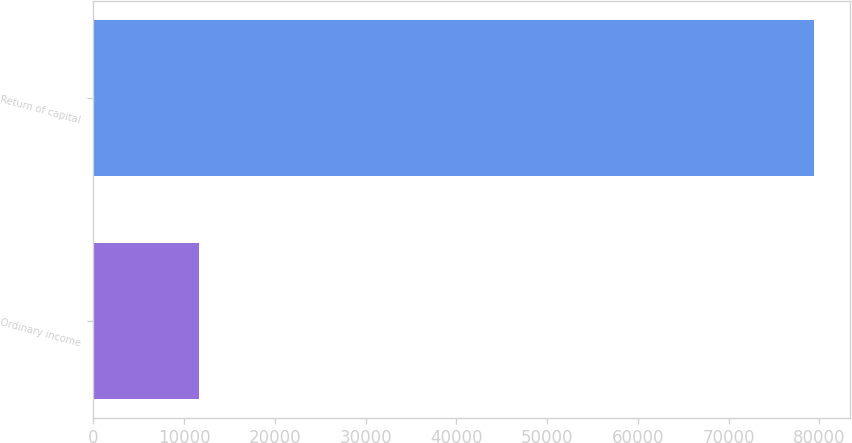Convert chart to OTSL. <chart><loc_0><loc_0><loc_500><loc_500><bar_chart><fcel>Ordinary income<fcel>Return of capital<nl><fcel>11638<fcel>79446<nl></chart> 